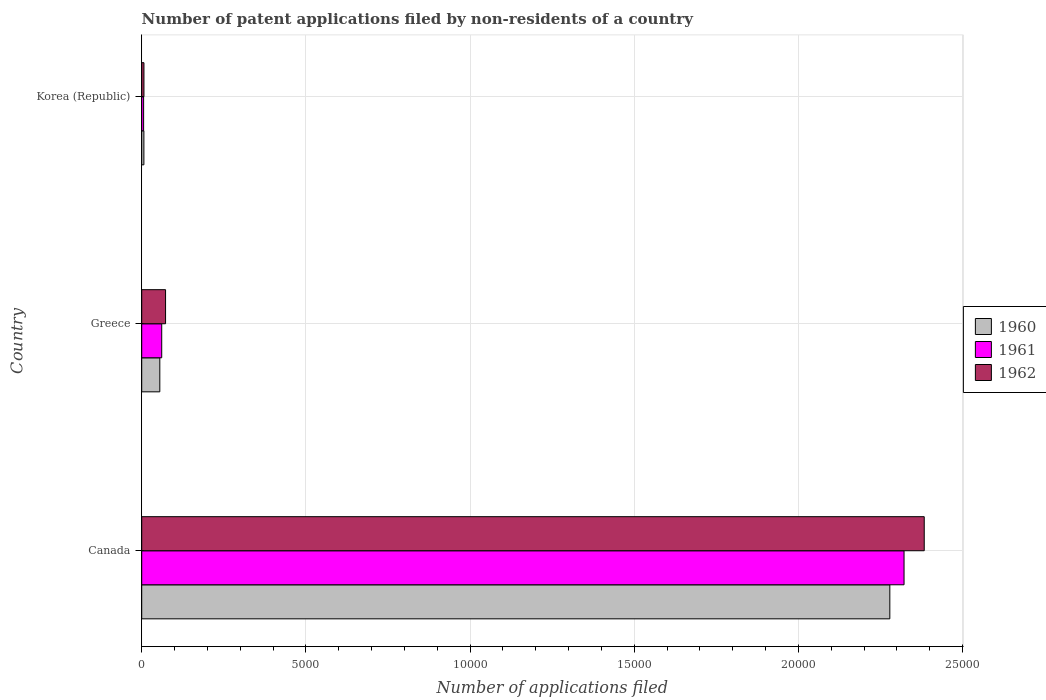How many different coloured bars are there?
Offer a terse response. 3. How many groups of bars are there?
Provide a succinct answer. 3. Are the number of bars per tick equal to the number of legend labels?
Keep it short and to the point. Yes. How many bars are there on the 2nd tick from the bottom?
Your answer should be very brief. 3. What is the number of applications filed in 1961 in Korea (Republic)?
Your answer should be compact. 58. Across all countries, what is the maximum number of applications filed in 1961?
Ensure brevity in your answer.  2.32e+04. Across all countries, what is the minimum number of applications filed in 1960?
Ensure brevity in your answer.  66. What is the total number of applications filed in 1960 in the graph?
Ensure brevity in your answer.  2.34e+04. What is the difference between the number of applications filed in 1960 in Canada and that in Korea (Republic)?
Your answer should be compact. 2.27e+04. What is the difference between the number of applications filed in 1960 in Greece and the number of applications filed in 1962 in Canada?
Your answer should be very brief. -2.33e+04. What is the average number of applications filed in 1962 per country?
Offer a terse response. 8209.33. What is the difference between the number of applications filed in 1961 and number of applications filed in 1960 in Canada?
Your response must be concise. 433. What is the ratio of the number of applications filed in 1962 in Greece to that in Korea (Republic)?
Your response must be concise. 10.68. Is the number of applications filed in 1961 in Canada less than that in Greece?
Offer a very short reply. No. Is the difference between the number of applications filed in 1961 in Canada and Greece greater than the difference between the number of applications filed in 1960 in Canada and Greece?
Offer a very short reply. Yes. What is the difference between the highest and the second highest number of applications filed in 1961?
Your answer should be very brief. 2.26e+04. What is the difference between the highest and the lowest number of applications filed in 1961?
Give a very brief answer. 2.32e+04. What does the 2nd bar from the top in Canada represents?
Provide a short and direct response. 1961. How many countries are there in the graph?
Keep it short and to the point. 3. Are the values on the major ticks of X-axis written in scientific E-notation?
Offer a terse response. No. Where does the legend appear in the graph?
Ensure brevity in your answer.  Center right. How many legend labels are there?
Your answer should be very brief. 3. How are the legend labels stacked?
Your response must be concise. Vertical. What is the title of the graph?
Offer a very short reply. Number of patent applications filed by non-residents of a country. Does "2014" appear as one of the legend labels in the graph?
Your answer should be very brief. No. What is the label or title of the X-axis?
Provide a succinct answer. Number of applications filed. What is the label or title of the Y-axis?
Make the answer very short. Country. What is the Number of applications filed in 1960 in Canada?
Provide a short and direct response. 2.28e+04. What is the Number of applications filed of 1961 in Canada?
Make the answer very short. 2.32e+04. What is the Number of applications filed of 1962 in Canada?
Offer a terse response. 2.38e+04. What is the Number of applications filed in 1960 in Greece?
Provide a succinct answer. 551. What is the Number of applications filed of 1961 in Greece?
Your response must be concise. 609. What is the Number of applications filed of 1962 in Greece?
Offer a terse response. 726. What is the Number of applications filed of 1962 in Korea (Republic)?
Offer a very short reply. 68. Across all countries, what is the maximum Number of applications filed in 1960?
Offer a very short reply. 2.28e+04. Across all countries, what is the maximum Number of applications filed of 1961?
Your answer should be very brief. 2.32e+04. Across all countries, what is the maximum Number of applications filed of 1962?
Offer a very short reply. 2.38e+04. Across all countries, what is the minimum Number of applications filed in 1960?
Offer a terse response. 66. Across all countries, what is the minimum Number of applications filed of 1961?
Your answer should be very brief. 58. What is the total Number of applications filed in 1960 in the graph?
Offer a very short reply. 2.34e+04. What is the total Number of applications filed of 1961 in the graph?
Provide a succinct answer. 2.39e+04. What is the total Number of applications filed of 1962 in the graph?
Your answer should be compact. 2.46e+04. What is the difference between the Number of applications filed in 1960 in Canada and that in Greece?
Keep it short and to the point. 2.22e+04. What is the difference between the Number of applications filed in 1961 in Canada and that in Greece?
Offer a terse response. 2.26e+04. What is the difference between the Number of applications filed of 1962 in Canada and that in Greece?
Keep it short and to the point. 2.31e+04. What is the difference between the Number of applications filed of 1960 in Canada and that in Korea (Republic)?
Offer a terse response. 2.27e+04. What is the difference between the Number of applications filed in 1961 in Canada and that in Korea (Republic)?
Ensure brevity in your answer.  2.32e+04. What is the difference between the Number of applications filed in 1962 in Canada and that in Korea (Republic)?
Provide a succinct answer. 2.38e+04. What is the difference between the Number of applications filed of 1960 in Greece and that in Korea (Republic)?
Make the answer very short. 485. What is the difference between the Number of applications filed in 1961 in Greece and that in Korea (Republic)?
Your answer should be compact. 551. What is the difference between the Number of applications filed of 1962 in Greece and that in Korea (Republic)?
Make the answer very short. 658. What is the difference between the Number of applications filed in 1960 in Canada and the Number of applications filed in 1961 in Greece?
Provide a succinct answer. 2.22e+04. What is the difference between the Number of applications filed in 1960 in Canada and the Number of applications filed in 1962 in Greece?
Offer a very short reply. 2.21e+04. What is the difference between the Number of applications filed of 1961 in Canada and the Number of applications filed of 1962 in Greece?
Your answer should be compact. 2.25e+04. What is the difference between the Number of applications filed in 1960 in Canada and the Number of applications filed in 1961 in Korea (Republic)?
Provide a succinct answer. 2.27e+04. What is the difference between the Number of applications filed of 1960 in Canada and the Number of applications filed of 1962 in Korea (Republic)?
Offer a terse response. 2.27e+04. What is the difference between the Number of applications filed in 1961 in Canada and the Number of applications filed in 1962 in Korea (Republic)?
Offer a very short reply. 2.32e+04. What is the difference between the Number of applications filed in 1960 in Greece and the Number of applications filed in 1961 in Korea (Republic)?
Offer a very short reply. 493. What is the difference between the Number of applications filed in 1960 in Greece and the Number of applications filed in 1962 in Korea (Republic)?
Provide a succinct answer. 483. What is the difference between the Number of applications filed of 1961 in Greece and the Number of applications filed of 1962 in Korea (Republic)?
Ensure brevity in your answer.  541. What is the average Number of applications filed in 1960 per country?
Make the answer very short. 7801. What is the average Number of applications filed in 1961 per country?
Give a very brief answer. 7962. What is the average Number of applications filed of 1962 per country?
Give a very brief answer. 8209.33. What is the difference between the Number of applications filed in 1960 and Number of applications filed in 1961 in Canada?
Keep it short and to the point. -433. What is the difference between the Number of applications filed of 1960 and Number of applications filed of 1962 in Canada?
Provide a succinct answer. -1048. What is the difference between the Number of applications filed in 1961 and Number of applications filed in 1962 in Canada?
Provide a short and direct response. -615. What is the difference between the Number of applications filed in 1960 and Number of applications filed in 1961 in Greece?
Offer a terse response. -58. What is the difference between the Number of applications filed of 1960 and Number of applications filed of 1962 in Greece?
Offer a terse response. -175. What is the difference between the Number of applications filed of 1961 and Number of applications filed of 1962 in Greece?
Make the answer very short. -117. What is the difference between the Number of applications filed of 1961 and Number of applications filed of 1962 in Korea (Republic)?
Your answer should be compact. -10. What is the ratio of the Number of applications filed in 1960 in Canada to that in Greece?
Your answer should be compact. 41.35. What is the ratio of the Number of applications filed in 1961 in Canada to that in Greece?
Offer a very short reply. 38.13. What is the ratio of the Number of applications filed of 1962 in Canada to that in Greece?
Keep it short and to the point. 32.83. What is the ratio of the Number of applications filed of 1960 in Canada to that in Korea (Republic)?
Your response must be concise. 345.24. What is the ratio of the Number of applications filed in 1961 in Canada to that in Korea (Republic)?
Make the answer very short. 400.33. What is the ratio of the Number of applications filed in 1962 in Canada to that in Korea (Republic)?
Ensure brevity in your answer.  350.5. What is the ratio of the Number of applications filed of 1960 in Greece to that in Korea (Republic)?
Offer a terse response. 8.35. What is the ratio of the Number of applications filed in 1961 in Greece to that in Korea (Republic)?
Your answer should be very brief. 10.5. What is the ratio of the Number of applications filed of 1962 in Greece to that in Korea (Republic)?
Offer a terse response. 10.68. What is the difference between the highest and the second highest Number of applications filed of 1960?
Provide a short and direct response. 2.22e+04. What is the difference between the highest and the second highest Number of applications filed of 1961?
Offer a terse response. 2.26e+04. What is the difference between the highest and the second highest Number of applications filed in 1962?
Offer a terse response. 2.31e+04. What is the difference between the highest and the lowest Number of applications filed in 1960?
Ensure brevity in your answer.  2.27e+04. What is the difference between the highest and the lowest Number of applications filed in 1961?
Make the answer very short. 2.32e+04. What is the difference between the highest and the lowest Number of applications filed of 1962?
Offer a very short reply. 2.38e+04. 